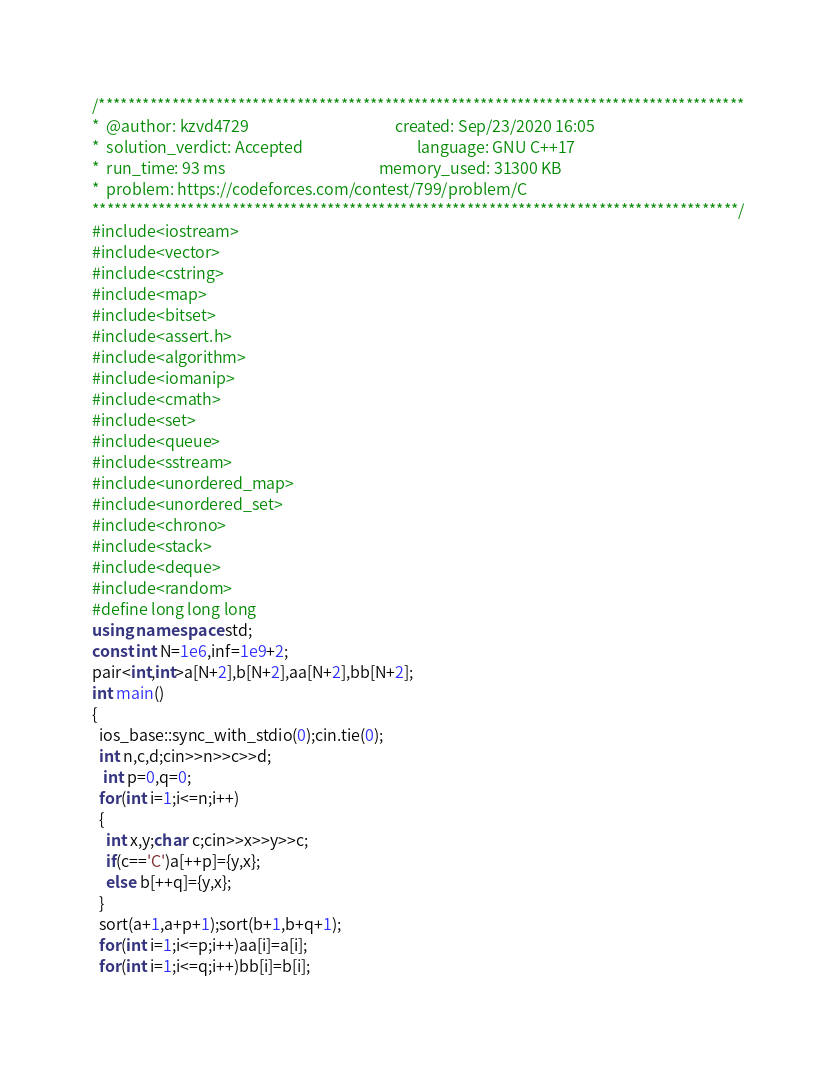<code> <loc_0><loc_0><loc_500><loc_500><_C++_>/****************************************************************************************
*  @author: kzvd4729                                         created: Sep/23/2020 16:05                        
*  solution_verdict: Accepted                                language: GNU C++17                               
*  run_time: 93 ms                                           memory_used: 31300 KB                             
*  problem: https://codeforces.com/contest/799/problem/C
****************************************************************************************/
#include<iostream>
#include<vector>
#include<cstring>
#include<map>
#include<bitset>
#include<assert.h>
#include<algorithm>
#include<iomanip>
#include<cmath>
#include<set>
#include<queue>
#include<sstream>
#include<unordered_map>
#include<unordered_set>
#include<chrono>
#include<stack>
#include<deque>
#include<random>
#define long long long 
using namespace std;
const int N=1e6,inf=1e9+2;
pair<int,int>a[N+2],b[N+2],aa[N+2],bb[N+2];
int main()
{
  ios_base::sync_with_stdio(0);cin.tie(0);
  int n,c,d;cin>>n>>c>>d;
   int p=0,q=0;
  for(int i=1;i<=n;i++)
  {
    int x,y;char c;cin>>x>>y>>c;
    if(c=='C')a[++p]={y,x};
    else b[++q]={y,x};
  }
  sort(a+1,a+p+1);sort(b+1,b+q+1);
  for(int i=1;i<=p;i++)aa[i]=a[i];
  for(int i=1;i<=q;i++)bb[i]=b[i];</code> 